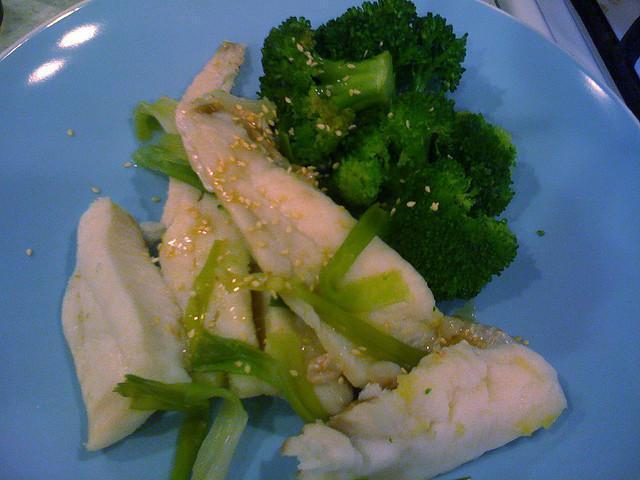How many slices of meat are on the plate?
Give a very brief answer. 5. How many different kinds of foods are here?
Give a very brief answer. 2. How many men are wearing a tie?
Give a very brief answer. 0. 